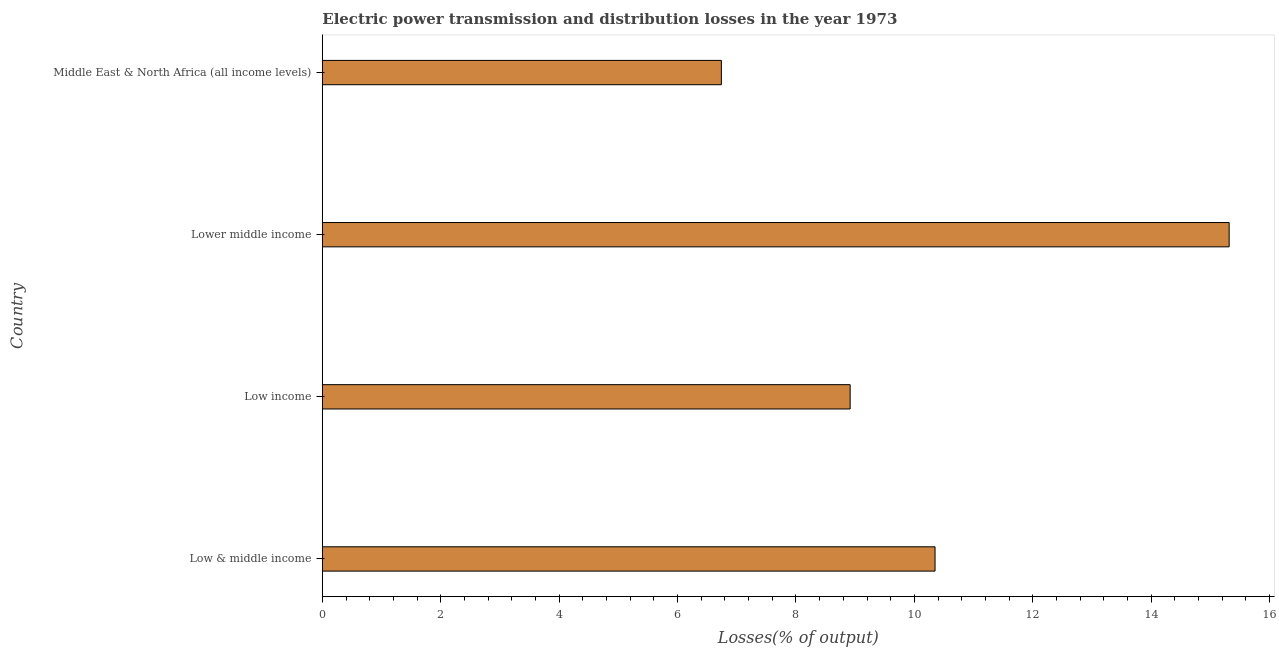Does the graph contain any zero values?
Your response must be concise. No. What is the title of the graph?
Make the answer very short. Electric power transmission and distribution losses in the year 1973. What is the label or title of the X-axis?
Provide a succinct answer. Losses(% of output). What is the electric power transmission and distribution losses in Low income?
Offer a very short reply. 8.92. Across all countries, what is the maximum electric power transmission and distribution losses?
Ensure brevity in your answer.  15.32. Across all countries, what is the minimum electric power transmission and distribution losses?
Your answer should be very brief. 6.74. In which country was the electric power transmission and distribution losses maximum?
Your answer should be compact. Lower middle income. In which country was the electric power transmission and distribution losses minimum?
Your response must be concise. Middle East & North Africa (all income levels). What is the sum of the electric power transmission and distribution losses?
Ensure brevity in your answer.  41.32. What is the difference between the electric power transmission and distribution losses in Low & middle income and Middle East & North Africa (all income levels)?
Offer a terse response. 3.61. What is the average electric power transmission and distribution losses per country?
Offer a terse response. 10.33. What is the median electric power transmission and distribution losses?
Your answer should be very brief. 9.63. What is the ratio of the electric power transmission and distribution losses in Low & middle income to that in Middle East & North Africa (all income levels)?
Provide a succinct answer. 1.53. Is the electric power transmission and distribution losses in Low income less than that in Lower middle income?
Provide a succinct answer. Yes. Is the difference between the electric power transmission and distribution losses in Low income and Lower middle income greater than the difference between any two countries?
Your answer should be compact. No. What is the difference between the highest and the second highest electric power transmission and distribution losses?
Provide a succinct answer. 4.97. Is the sum of the electric power transmission and distribution losses in Low & middle income and Low income greater than the maximum electric power transmission and distribution losses across all countries?
Keep it short and to the point. Yes. What is the difference between the highest and the lowest electric power transmission and distribution losses?
Offer a terse response. 8.58. In how many countries, is the electric power transmission and distribution losses greater than the average electric power transmission and distribution losses taken over all countries?
Offer a terse response. 2. How many countries are there in the graph?
Your response must be concise. 4. What is the difference between two consecutive major ticks on the X-axis?
Your response must be concise. 2. What is the Losses(% of output) of Low & middle income?
Give a very brief answer. 10.35. What is the Losses(% of output) of Low income?
Offer a terse response. 8.92. What is the Losses(% of output) in Lower middle income?
Make the answer very short. 15.32. What is the Losses(% of output) of Middle East & North Africa (all income levels)?
Offer a terse response. 6.74. What is the difference between the Losses(% of output) in Low & middle income and Low income?
Keep it short and to the point. 1.43. What is the difference between the Losses(% of output) in Low & middle income and Lower middle income?
Offer a terse response. -4.97. What is the difference between the Losses(% of output) in Low & middle income and Middle East & North Africa (all income levels)?
Your answer should be compact. 3.61. What is the difference between the Losses(% of output) in Low income and Lower middle income?
Ensure brevity in your answer.  -6.4. What is the difference between the Losses(% of output) in Low income and Middle East & North Africa (all income levels)?
Your answer should be compact. 2.18. What is the difference between the Losses(% of output) in Lower middle income and Middle East & North Africa (all income levels)?
Give a very brief answer. 8.58. What is the ratio of the Losses(% of output) in Low & middle income to that in Low income?
Your answer should be very brief. 1.16. What is the ratio of the Losses(% of output) in Low & middle income to that in Lower middle income?
Your answer should be very brief. 0.68. What is the ratio of the Losses(% of output) in Low & middle income to that in Middle East & North Africa (all income levels)?
Offer a terse response. 1.53. What is the ratio of the Losses(% of output) in Low income to that in Lower middle income?
Give a very brief answer. 0.58. What is the ratio of the Losses(% of output) in Low income to that in Middle East & North Africa (all income levels)?
Offer a very short reply. 1.32. What is the ratio of the Losses(% of output) in Lower middle income to that in Middle East & North Africa (all income levels)?
Give a very brief answer. 2.27. 